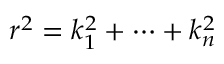Convert formula to latex. <formula><loc_0><loc_0><loc_500><loc_500>r ^ { 2 } = k _ { 1 } ^ { 2 } + \cdots + k _ { n } ^ { 2 }</formula> 